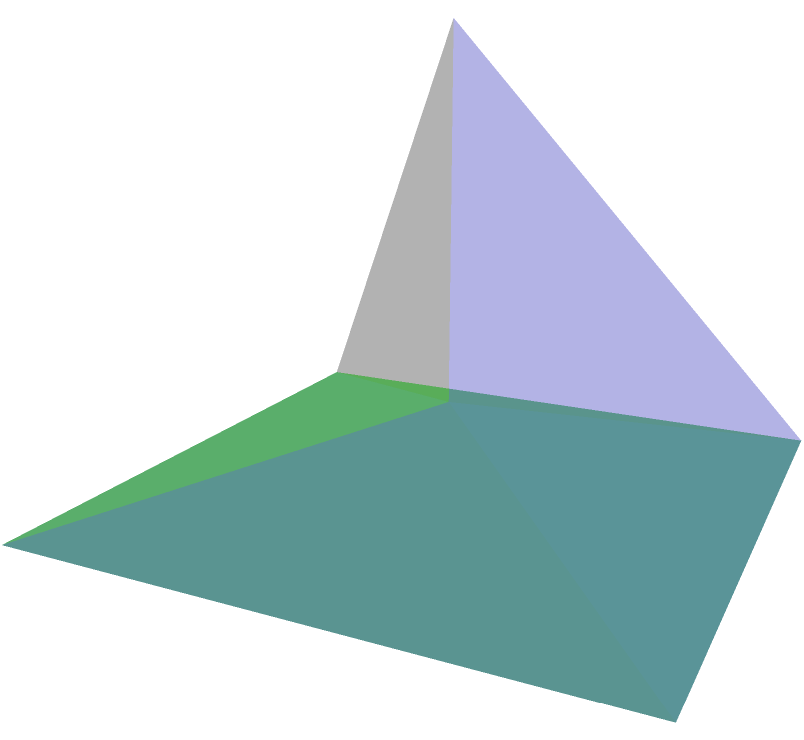A monument commemorating human rights in Santiago is shaped like a pyramid with a square base. If the base measures 4 meters on each side and the height of the pyramid is 3 meters, what is the volume of this monument in cubic meters? To calculate the volume of a pyramid, we use the formula:

$$V = \frac{1}{3} \times B \times h$$

Where:
$V$ = Volume
$B$ = Area of the base
$h$ = Height of the pyramid

Let's solve this step-by-step:

1. Calculate the area of the base (B):
   The base is a square with side length 4 m.
   $$B = 4 \text{ m} \times 4 \text{ m} = 16 \text{ m}^2$$

2. We're given the height (h) of the pyramid:
   $$h = 3 \text{ m}$$

3. Now, let's substitute these values into the volume formula:
   $$V = \frac{1}{3} \times 16 \text{ m}^2 \times 3 \text{ m}$$

4. Simplify:
   $$V = \frac{1}{3} \times 48 \text{ m}^3 = 16 \text{ m}^3$$

Therefore, the volume of the pyramid-shaped monument is 16 cubic meters.
Answer: 16 m³ 